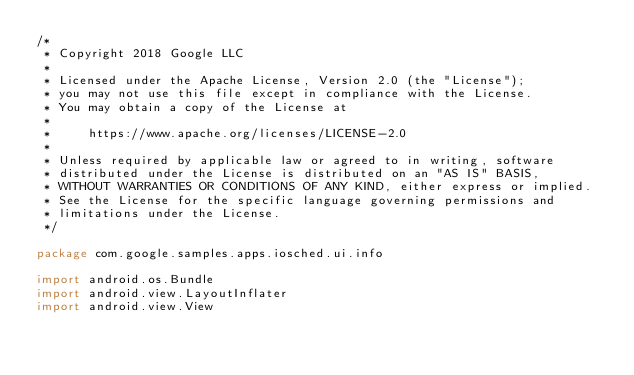Convert code to text. <code><loc_0><loc_0><loc_500><loc_500><_Kotlin_>/*
 * Copyright 2018 Google LLC
 *
 * Licensed under the Apache License, Version 2.0 (the "License");
 * you may not use this file except in compliance with the License.
 * You may obtain a copy of the License at
 *
 *     https://www.apache.org/licenses/LICENSE-2.0
 *
 * Unless required by applicable law or agreed to in writing, software
 * distributed under the License is distributed on an "AS IS" BASIS,
 * WITHOUT WARRANTIES OR CONDITIONS OF ANY KIND, either express or implied.
 * See the License for the specific language governing permissions and
 * limitations under the License.
 */

package com.google.samples.apps.iosched.ui.info

import android.os.Bundle
import android.view.LayoutInflater
import android.view.View</code> 